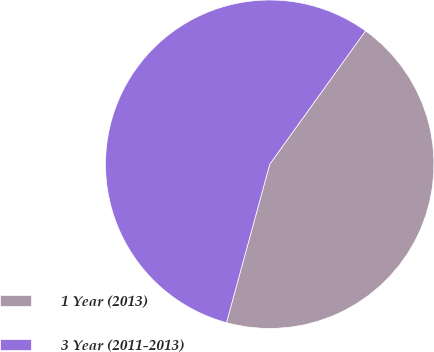Convert chart to OTSL. <chart><loc_0><loc_0><loc_500><loc_500><pie_chart><fcel>1 Year (2013)<fcel>3 Year (2011-2013)<nl><fcel>44.33%<fcel>55.67%<nl></chart> 